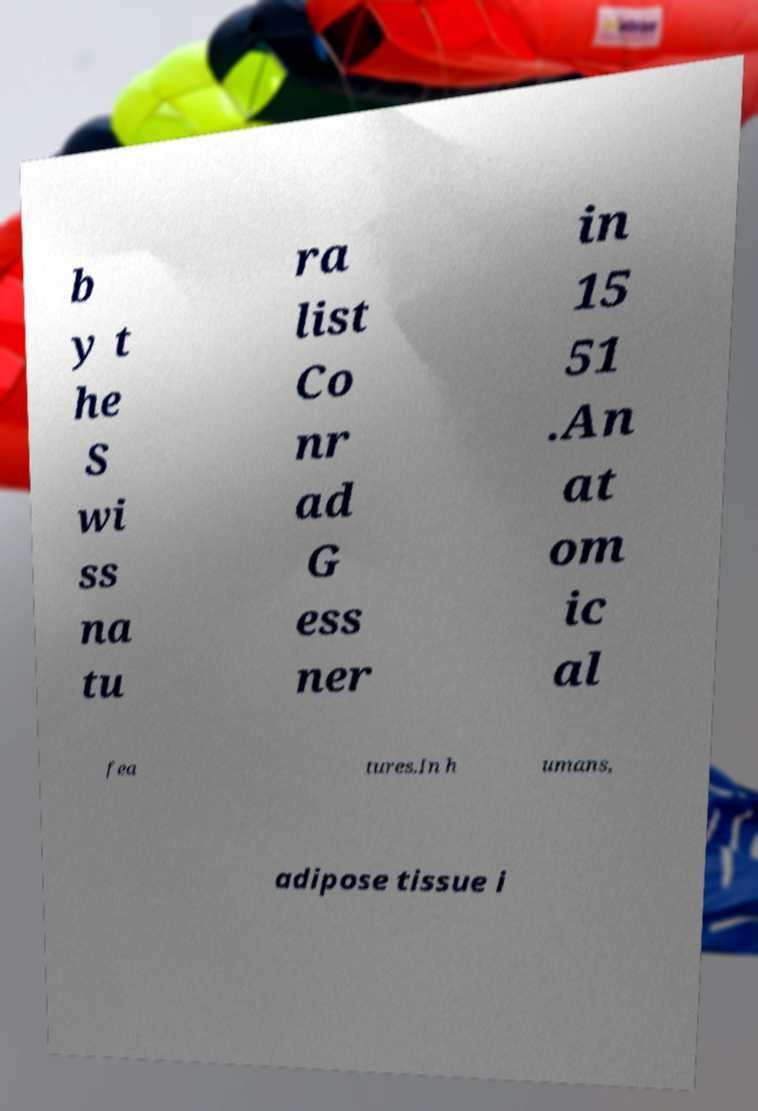There's text embedded in this image that I need extracted. Can you transcribe it verbatim? b y t he S wi ss na tu ra list Co nr ad G ess ner in 15 51 .An at om ic al fea tures.In h umans, adipose tissue i 